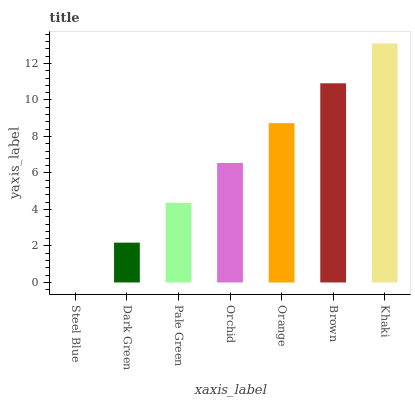Is Steel Blue the minimum?
Answer yes or no. Yes. Is Khaki the maximum?
Answer yes or no. Yes. Is Dark Green the minimum?
Answer yes or no. No. Is Dark Green the maximum?
Answer yes or no. No. Is Dark Green greater than Steel Blue?
Answer yes or no. Yes. Is Steel Blue less than Dark Green?
Answer yes or no. Yes. Is Steel Blue greater than Dark Green?
Answer yes or no. No. Is Dark Green less than Steel Blue?
Answer yes or no. No. Is Orchid the high median?
Answer yes or no. Yes. Is Orchid the low median?
Answer yes or no. Yes. Is Steel Blue the high median?
Answer yes or no. No. Is Pale Green the low median?
Answer yes or no. No. 